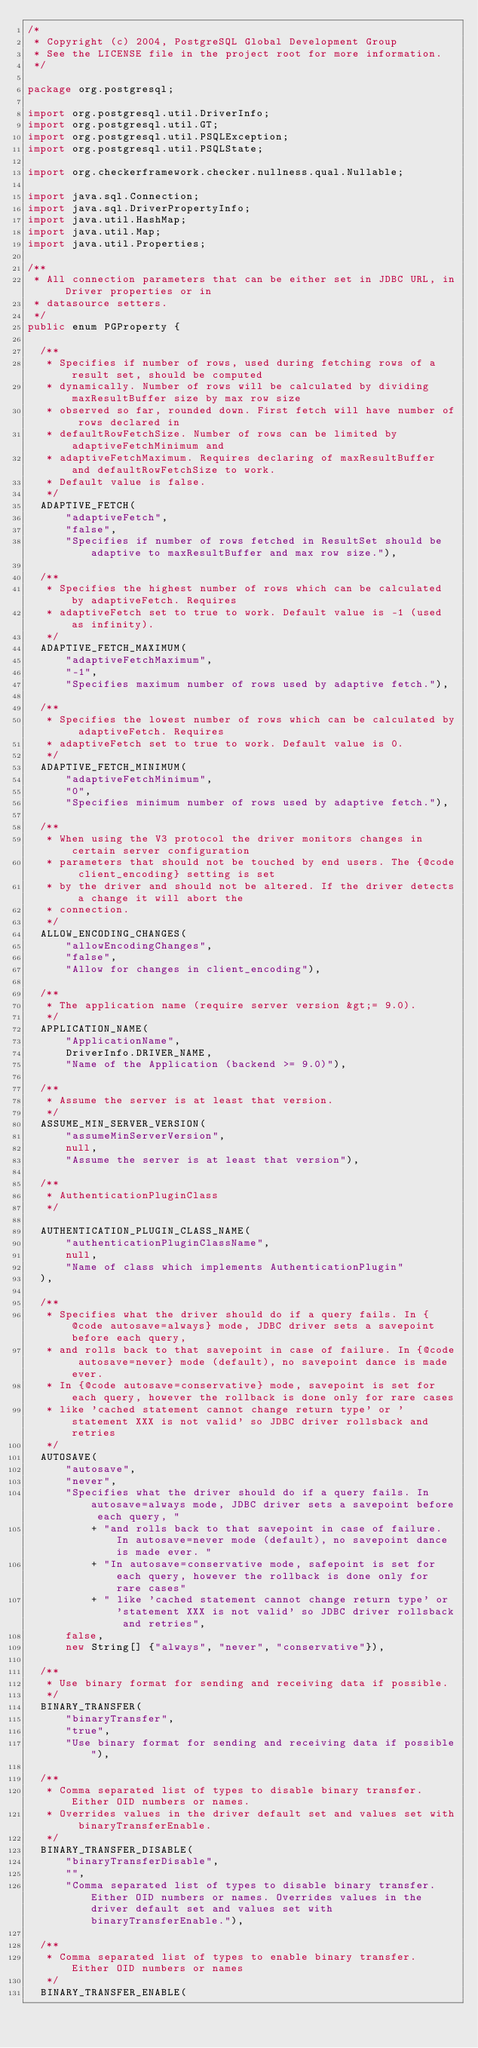<code> <loc_0><loc_0><loc_500><loc_500><_Java_>/*
 * Copyright (c) 2004, PostgreSQL Global Development Group
 * See the LICENSE file in the project root for more information.
 */

package org.postgresql;

import org.postgresql.util.DriverInfo;
import org.postgresql.util.GT;
import org.postgresql.util.PSQLException;
import org.postgresql.util.PSQLState;

import org.checkerframework.checker.nullness.qual.Nullable;

import java.sql.Connection;
import java.sql.DriverPropertyInfo;
import java.util.HashMap;
import java.util.Map;
import java.util.Properties;

/**
 * All connection parameters that can be either set in JDBC URL, in Driver properties or in
 * datasource setters.
 */
public enum PGProperty {

  /**
   * Specifies if number of rows, used during fetching rows of a result set, should be computed
   * dynamically. Number of rows will be calculated by dividing maxResultBuffer size by max row size
   * observed so far, rounded down. First fetch will have number of rows declared in
   * defaultRowFetchSize. Number of rows can be limited by adaptiveFetchMinimum and
   * adaptiveFetchMaximum. Requires declaring of maxResultBuffer and defaultRowFetchSize to work.
   * Default value is false.
   */
  ADAPTIVE_FETCH(
      "adaptiveFetch",
      "false",
      "Specifies if number of rows fetched in ResultSet should be adaptive to maxResultBuffer and max row size."),

  /**
   * Specifies the highest number of rows which can be calculated by adaptiveFetch. Requires
   * adaptiveFetch set to true to work. Default value is -1 (used as infinity).
   */
  ADAPTIVE_FETCH_MAXIMUM(
      "adaptiveFetchMaximum",
      "-1",
      "Specifies maximum number of rows used by adaptive fetch."),

  /**
   * Specifies the lowest number of rows which can be calculated by adaptiveFetch. Requires
   * adaptiveFetch set to true to work. Default value is 0.
   */
  ADAPTIVE_FETCH_MINIMUM(
      "adaptiveFetchMinimum",
      "0",
      "Specifies minimum number of rows used by adaptive fetch."),

  /**
   * When using the V3 protocol the driver monitors changes in certain server configuration
   * parameters that should not be touched by end users. The {@code client_encoding} setting is set
   * by the driver and should not be altered. If the driver detects a change it will abort the
   * connection.
   */
  ALLOW_ENCODING_CHANGES(
      "allowEncodingChanges",
      "false",
      "Allow for changes in client_encoding"),

  /**
   * The application name (require server version &gt;= 9.0).
   */
  APPLICATION_NAME(
      "ApplicationName",
      DriverInfo.DRIVER_NAME,
      "Name of the Application (backend >= 9.0)"),

  /**
   * Assume the server is at least that version.
   */
  ASSUME_MIN_SERVER_VERSION(
      "assumeMinServerVersion",
      null,
      "Assume the server is at least that version"),

  /**
   * AuthenticationPluginClass
   */

  AUTHENTICATION_PLUGIN_CLASS_NAME(
      "authenticationPluginClassName",
      null,
      "Name of class which implements AuthenticationPlugin"
  ),

  /**
   * Specifies what the driver should do if a query fails. In {@code autosave=always} mode, JDBC driver sets a savepoint before each query,
   * and rolls back to that savepoint in case of failure. In {@code autosave=never} mode (default), no savepoint dance is made ever.
   * In {@code autosave=conservative} mode, savepoint is set for each query, however the rollback is done only for rare cases
   * like 'cached statement cannot change return type' or 'statement XXX is not valid' so JDBC driver rollsback and retries
   */
  AUTOSAVE(
      "autosave",
      "never",
      "Specifies what the driver should do if a query fails. In autosave=always mode, JDBC driver sets a savepoint before each query, "
          + "and rolls back to that savepoint in case of failure. In autosave=never mode (default), no savepoint dance is made ever. "
          + "In autosave=conservative mode, safepoint is set for each query, however the rollback is done only for rare cases"
          + " like 'cached statement cannot change return type' or 'statement XXX is not valid' so JDBC driver rollsback and retries",
      false,
      new String[] {"always", "never", "conservative"}),

  /**
   * Use binary format for sending and receiving data if possible.
   */
  BINARY_TRANSFER(
      "binaryTransfer",
      "true",
      "Use binary format for sending and receiving data if possible"),

  /**
   * Comma separated list of types to disable binary transfer. Either OID numbers or names.
   * Overrides values in the driver default set and values set with binaryTransferEnable.
   */
  BINARY_TRANSFER_DISABLE(
      "binaryTransferDisable",
      "",
      "Comma separated list of types to disable binary transfer. Either OID numbers or names. Overrides values in the driver default set and values set with binaryTransferEnable."),

  /**
   * Comma separated list of types to enable binary transfer. Either OID numbers or names
   */
  BINARY_TRANSFER_ENABLE(</code> 